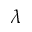Convert formula to latex. <formula><loc_0><loc_0><loc_500><loc_500>\lambda</formula> 